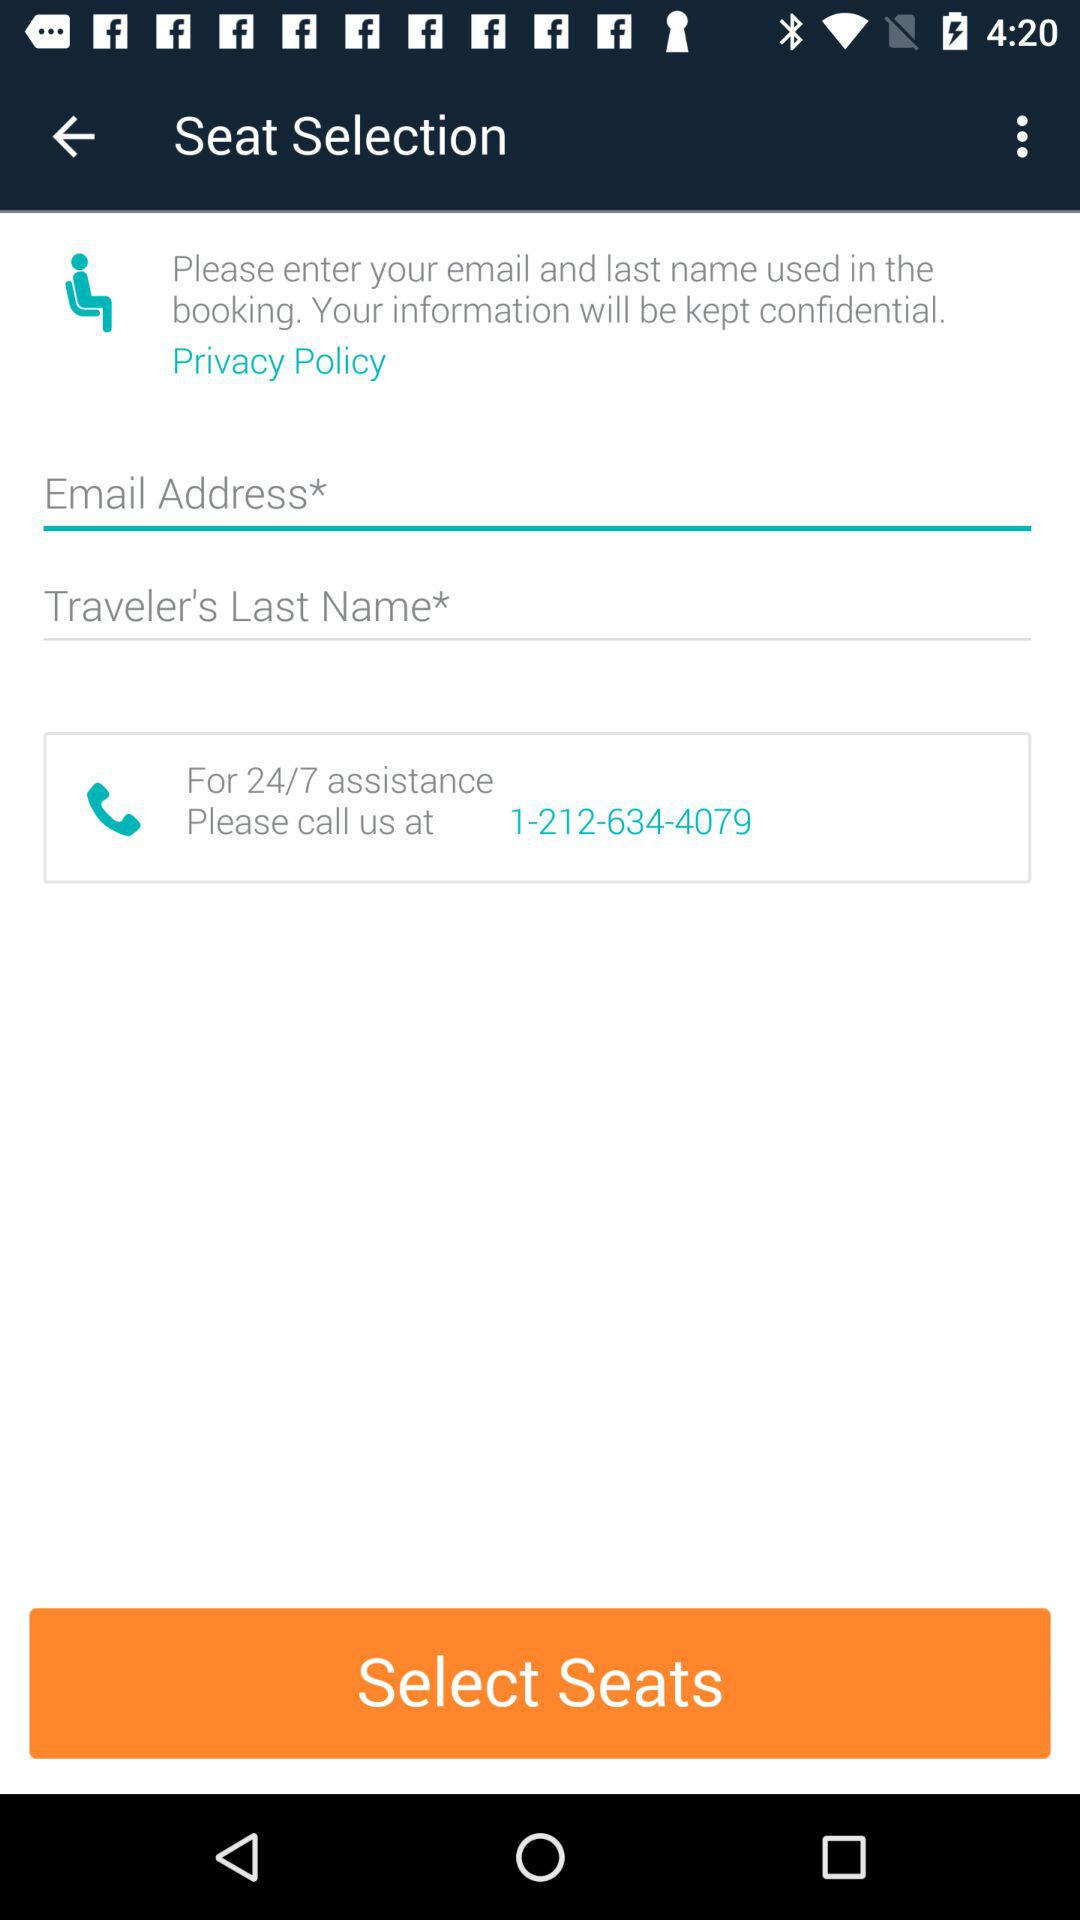How many text inputs are required to enter the contact information?
Answer the question using a single word or phrase. 2 